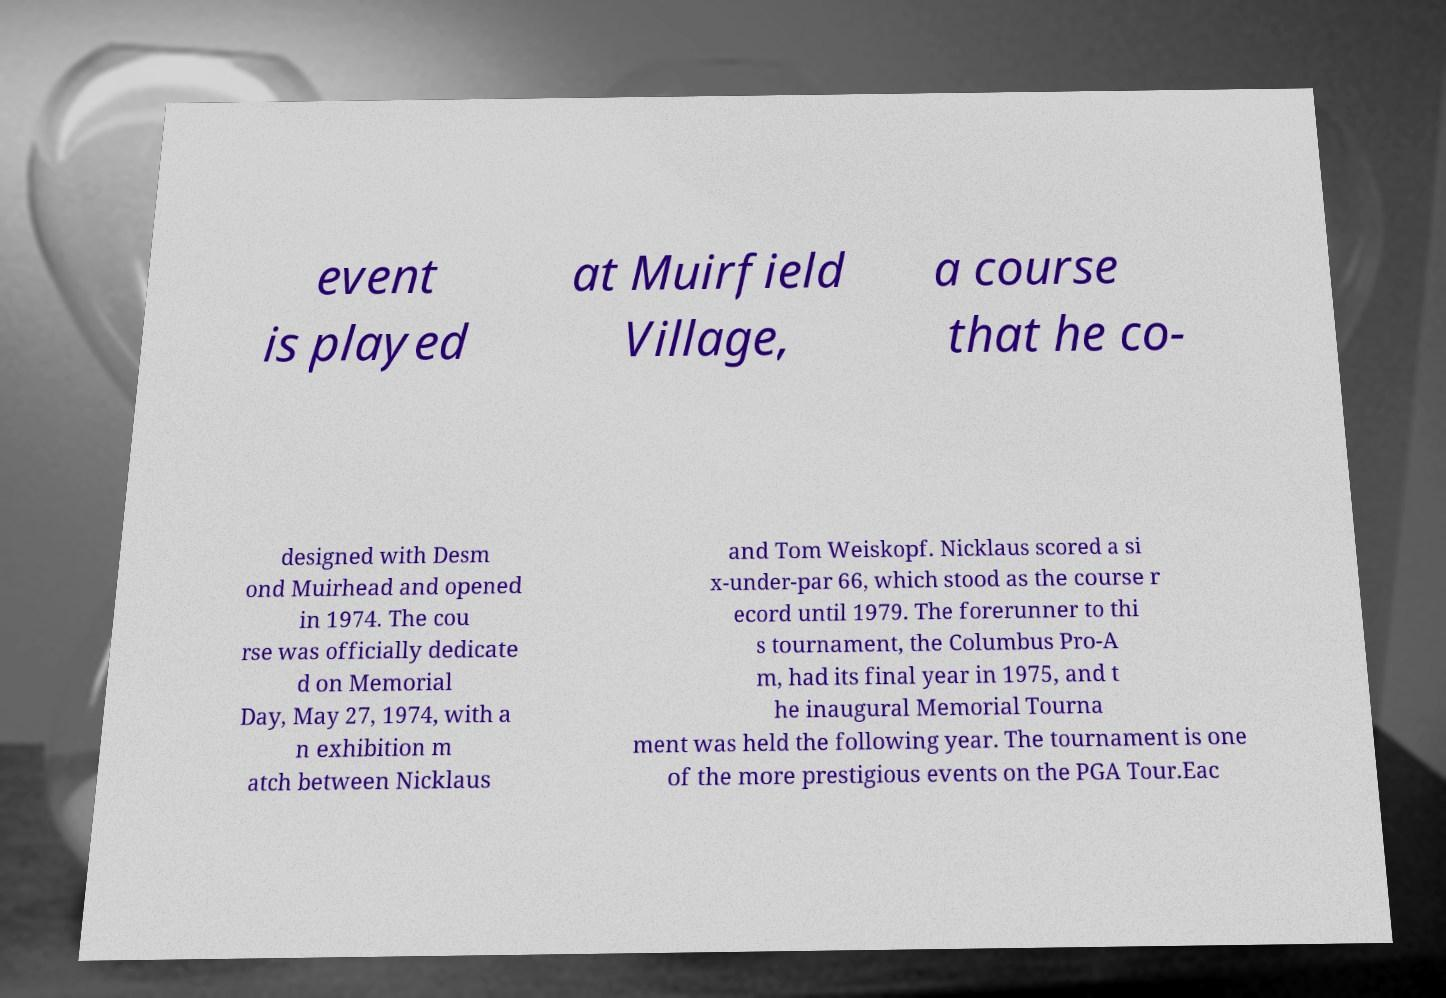Please read and relay the text visible in this image. What does it say? event is played at Muirfield Village, a course that he co- designed with Desm ond Muirhead and opened in 1974. The cou rse was officially dedicate d on Memorial Day, May 27, 1974, with a n exhibition m atch between Nicklaus and Tom Weiskopf. Nicklaus scored a si x-under-par 66, which stood as the course r ecord until 1979. The forerunner to thi s tournament, the Columbus Pro-A m, had its final year in 1975, and t he inaugural Memorial Tourna ment was held the following year. The tournament is one of the more prestigious events on the PGA Tour.Eac 